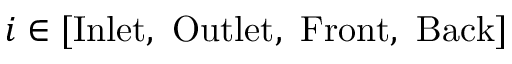Convert formula to latex. <formula><loc_0><loc_0><loc_500><loc_500>i \in [ I n l e t , \ O u t l e t , \ F r o n t , \ B a c k ]</formula> 